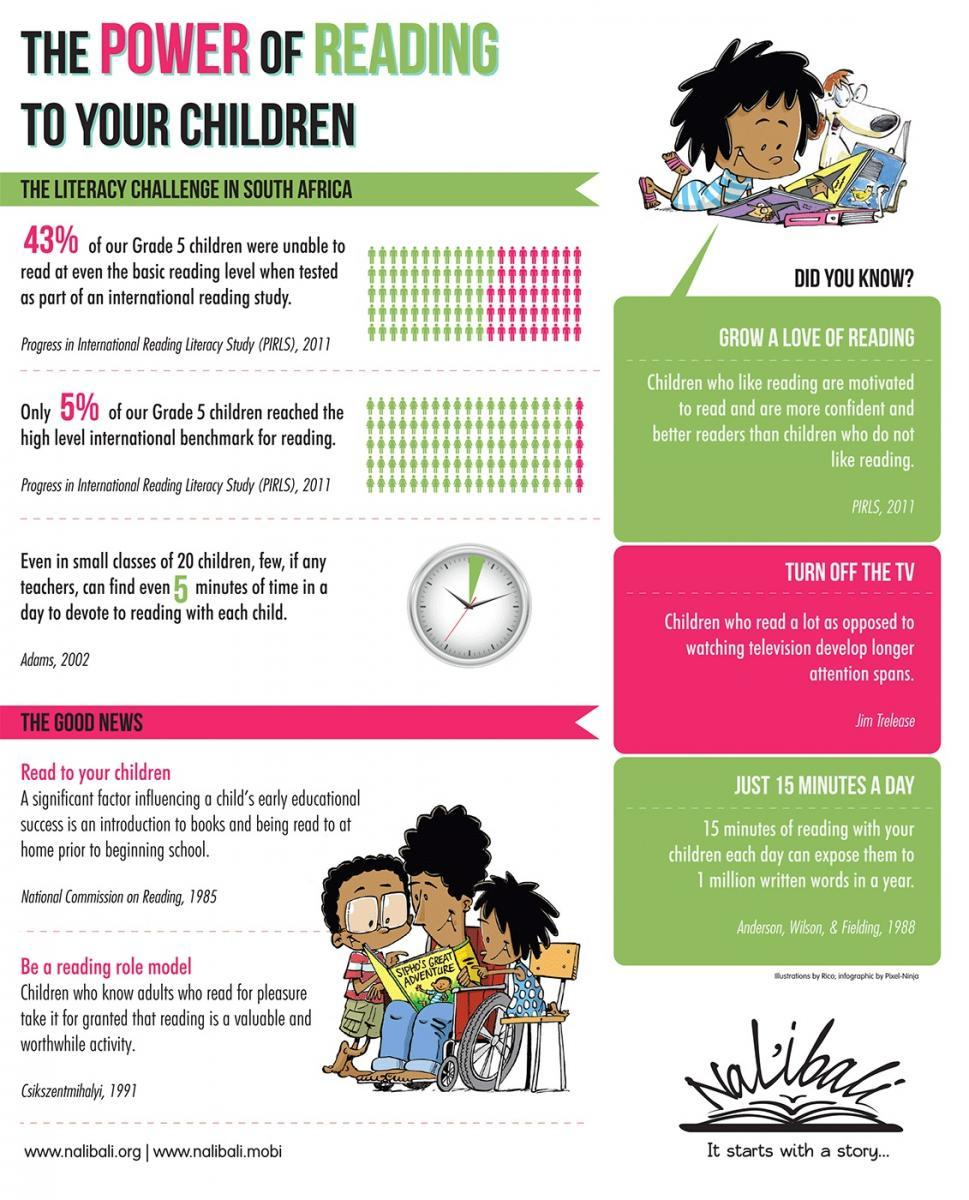Identify some key points in this picture. According to a recent study, a significant percentage of grade 5 children in South Africa were unable to read at a basic reading level. Specifically, 57% of the children were found to be struggling with basic literacy skills. This is a concerning issue that requires immediate attention and action from educators and policymakers. It is recommended that parents read to their children on a regular basis and serve as reading role models in order to promote good literacy development. The title of the book is "Sipho's Great Adventure. The green portion in the clock indicates 3 minutes. Reading with your children for just 15 minutes per day is sufficient to expose them to one million written words in a year, as recommended for early language development. 